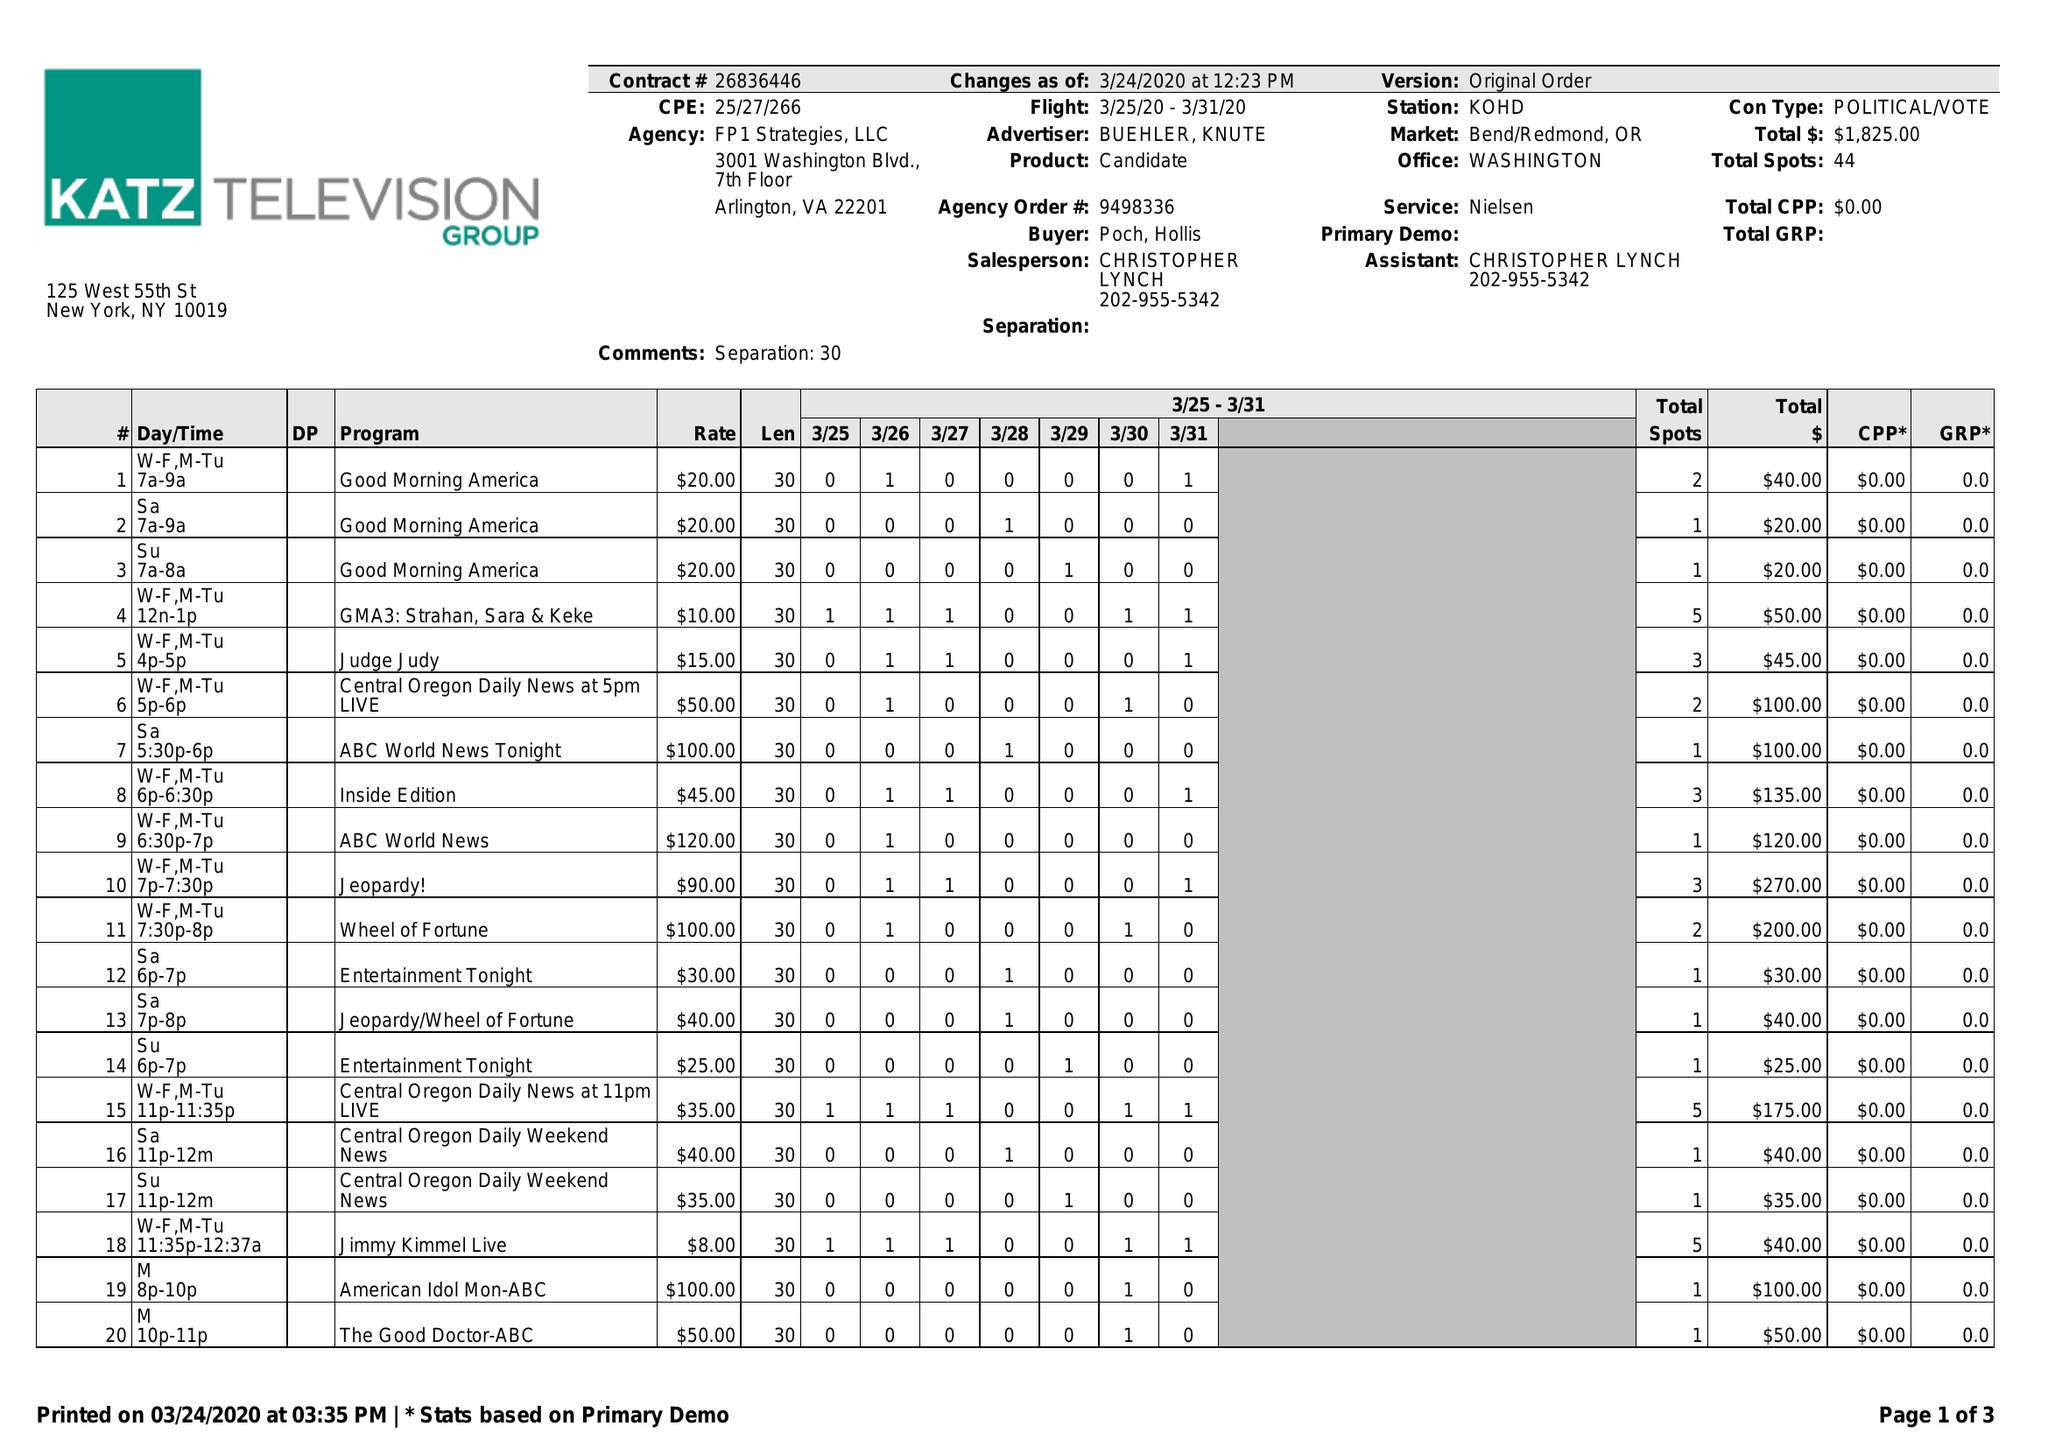What is the value for the contract_num?
Answer the question using a single word or phrase. 26836446 